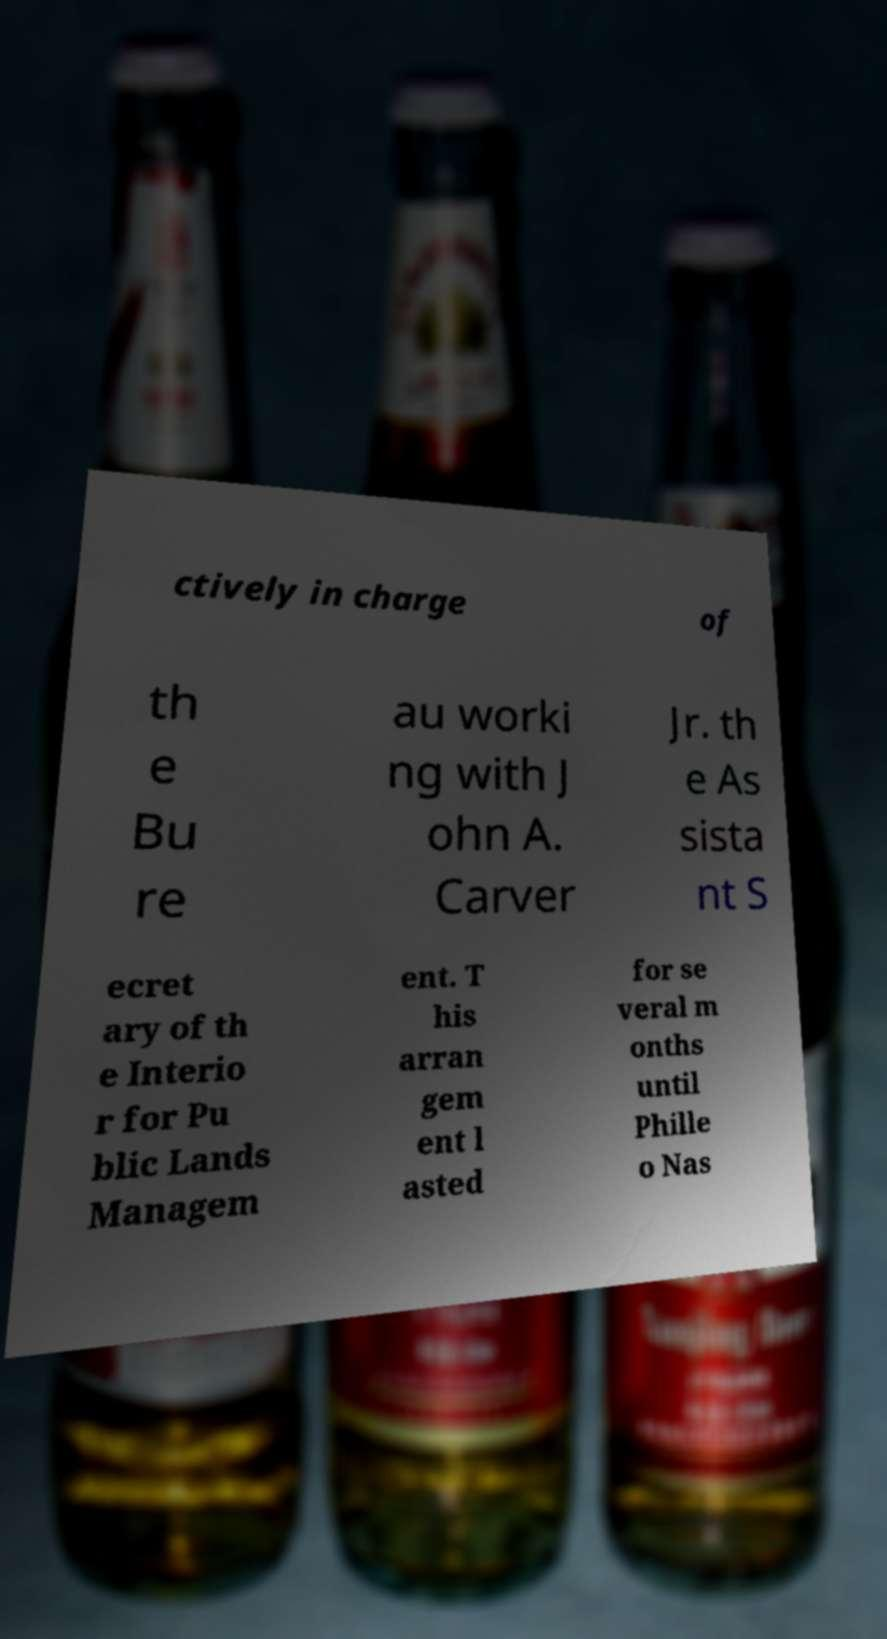Could you assist in decoding the text presented in this image and type it out clearly? ctively in charge of th e Bu re au worki ng with J ohn A. Carver Jr. th e As sista nt S ecret ary of th e Interio r for Pu blic Lands Managem ent. T his arran gem ent l asted for se veral m onths until Phille o Nas 